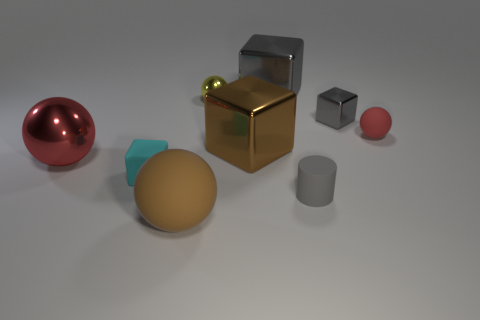Subtract all brown spheres. How many spheres are left? 3 Subtract all tiny cyan blocks. How many blocks are left? 3 Subtract all gray spheres. Subtract all green cylinders. How many spheres are left? 4 Subtract all blocks. How many objects are left? 5 Subtract all cyan rubber cubes. Subtract all small yellow metallic balls. How many objects are left? 7 Add 9 cylinders. How many cylinders are left? 10 Add 4 tiny cyan objects. How many tiny cyan objects exist? 5 Subtract 0 purple balls. How many objects are left? 9 